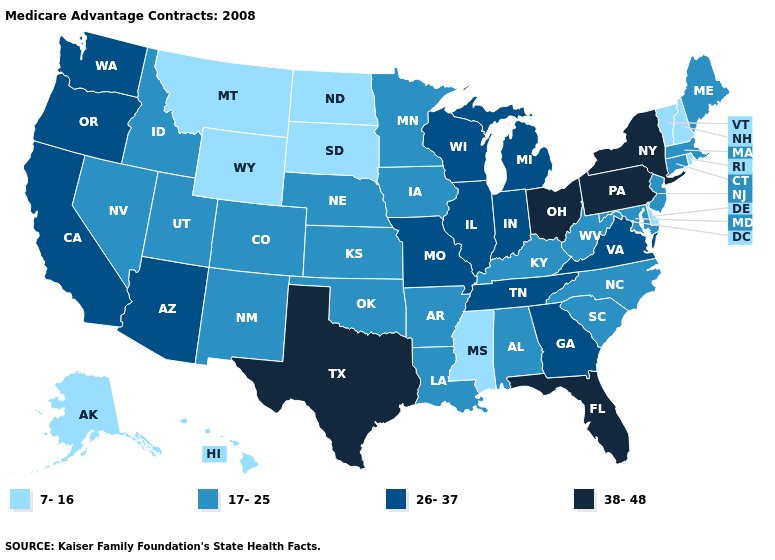Does Florida have a higher value than New York?
Concise answer only. No. Is the legend a continuous bar?
Quick response, please. No. Does Tennessee have a lower value than New York?
Answer briefly. Yes. What is the value of New Jersey?
Be succinct. 17-25. What is the value of Oklahoma?
Answer briefly. 17-25. Name the states that have a value in the range 26-37?
Be succinct. Arizona, California, Georgia, Illinois, Indiana, Michigan, Missouri, Oregon, Tennessee, Virginia, Washington, Wisconsin. Name the states that have a value in the range 38-48?
Give a very brief answer. Florida, New York, Ohio, Pennsylvania, Texas. Which states have the lowest value in the USA?
Answer briefly. Alaska, Delaware, Hawaii, Mississippi, Montana, North Dakota, New Hampshire, Rhode Island, South Dakota, Vermont, Wyoming. What is the value of Idaho?
Concise answer only. 17-25. What is the value of New Jersey?
Keep it brief. 17-25. Does West Virginia have the same value as Missouri?
Write a very short answer. No. Name the states that have a value in the range 17-25?
Concise answer only. Alabama, Arkansas, Colorado, Connecticut, Iowa, Idaho, Kansas, Kentucky, Louisiana, Massachusetts, Maryland, Maine, Minnesota, North Carolina, Nebraska, New Jersey, New Mexico, Nevada, Oklahoma, South Carolina, Utah, West Virginia. Is the legend a continuous bar?
Short answer required. No. Among the states that border Arizona , does Nevada have the lowest value?
Write a very short answer. Yes. Name the states that have a value in the range 7-16?
Keep it brief. Alaska, Delaware, Hawaii, Mississippi, Montana, North Dakota, New Hampshire, Rhode Island, South Dakota, Vermont, Wyoming. 